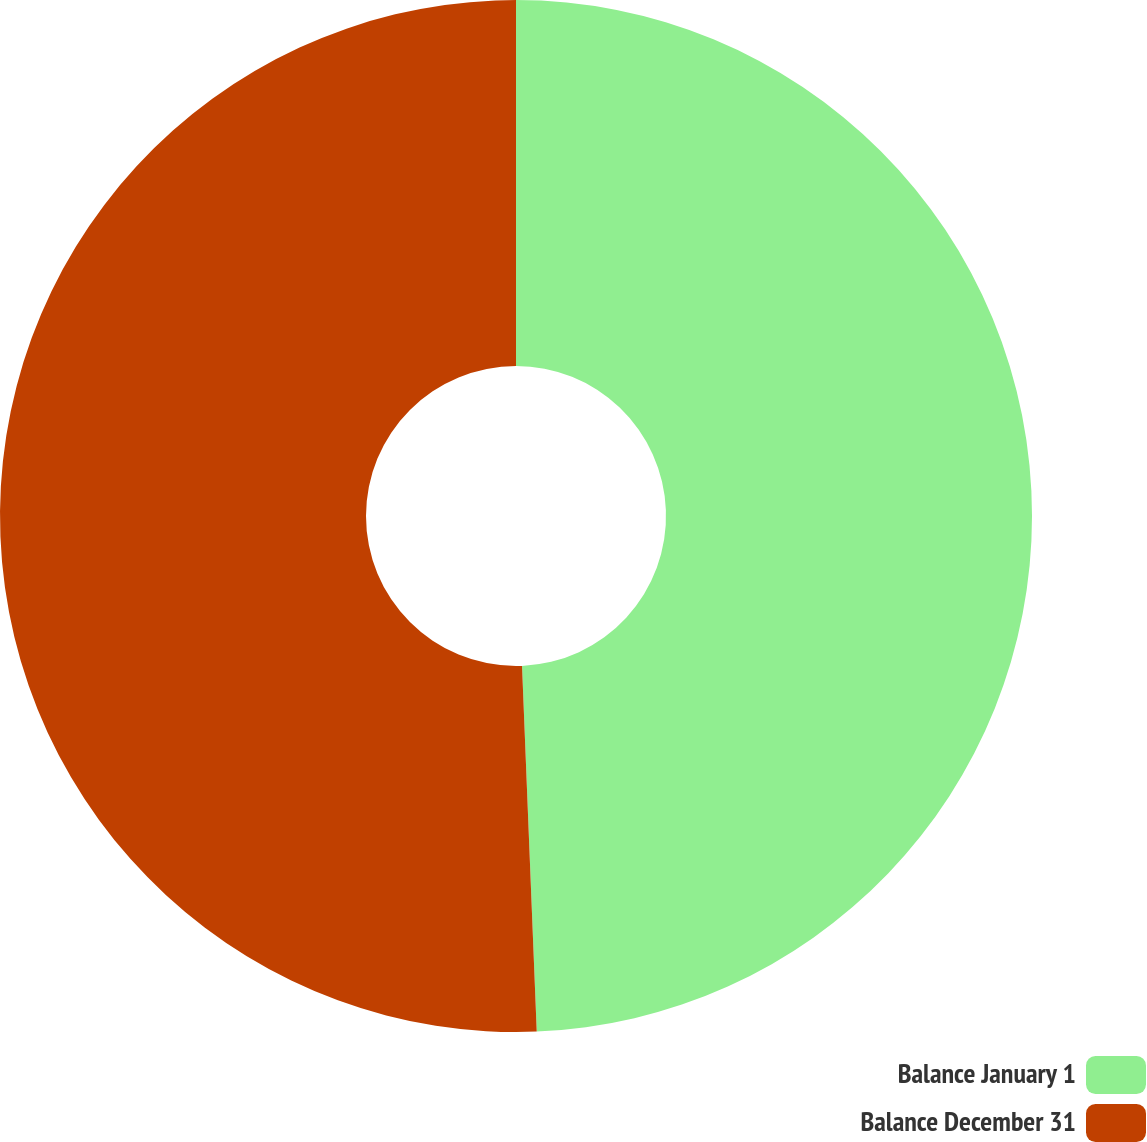Convert chart. <chart><loc_0><loc_0><loc_500><loc_500><pie_chart><fcel>Balance January 1<fcel>Balance December 31<nl><fcel>49.36%<fcel>50.64%<nl></chart> 